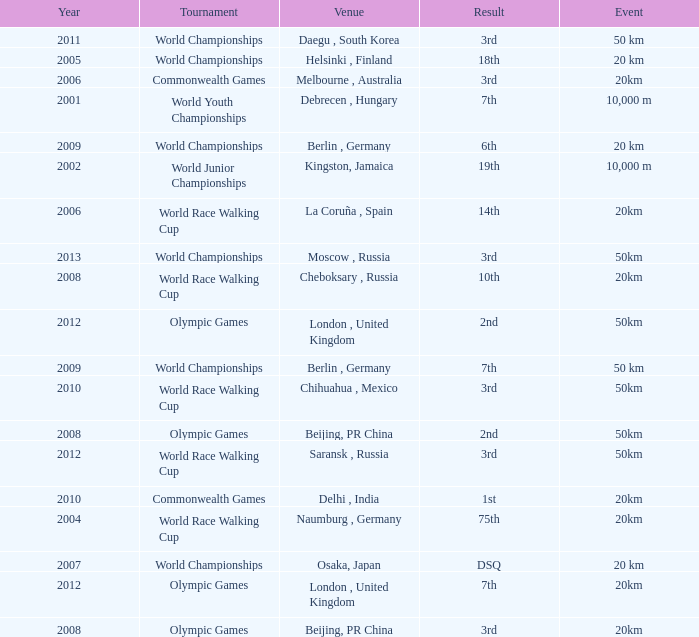What is the result of the World Race Walking Cup tournament played before the year 2010? 3rd. 